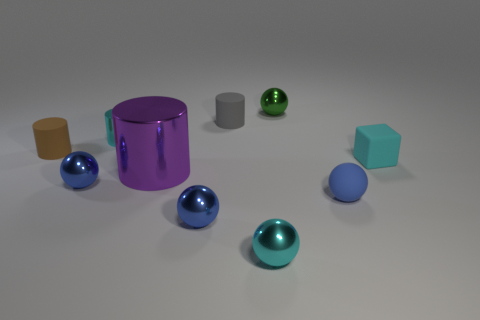There is a tiny metallic sphere behind the small cyan thing to the right of the tiny green sphere; what color is it?
Your answer should be compact. Green. How many big objects are either purple objects or red shiny cubes?
Provide a succinct answer. 1. There is a small cyan thing that is the same shape as the gray matte object; what material is it?
Make the answer very short. Metal. Are there any other things that have the same material as the big object?
Provide a short and direct response. Yes. The rubber ball is what color?
Ensure brevity in your answer.  Blue. Do the small rubber sphere and the small cube have the same color?
Give a very brief answer. No. What number of small cyan blocks are left of the small metal ball that is on the left side of the big metallic thing?
Your answer should be compact. 0. There is a metal thing that is behind the big cylinder and in front of the tiny gray matte cylinder; how big is it?
Make the answer very short. Small. There is a object that is right of the blue matte sphere; what is it made of?
Your response must be concise. Rubber. Are there any small green objects of the same shape as the large purple thing?
Your response must be concise. No. 